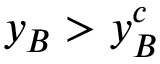Convert formula to latex. <formula><loc_0><loc_0><loc_500><loc_500>y _ { B } > y _ { B } ^ { c }</formula> 